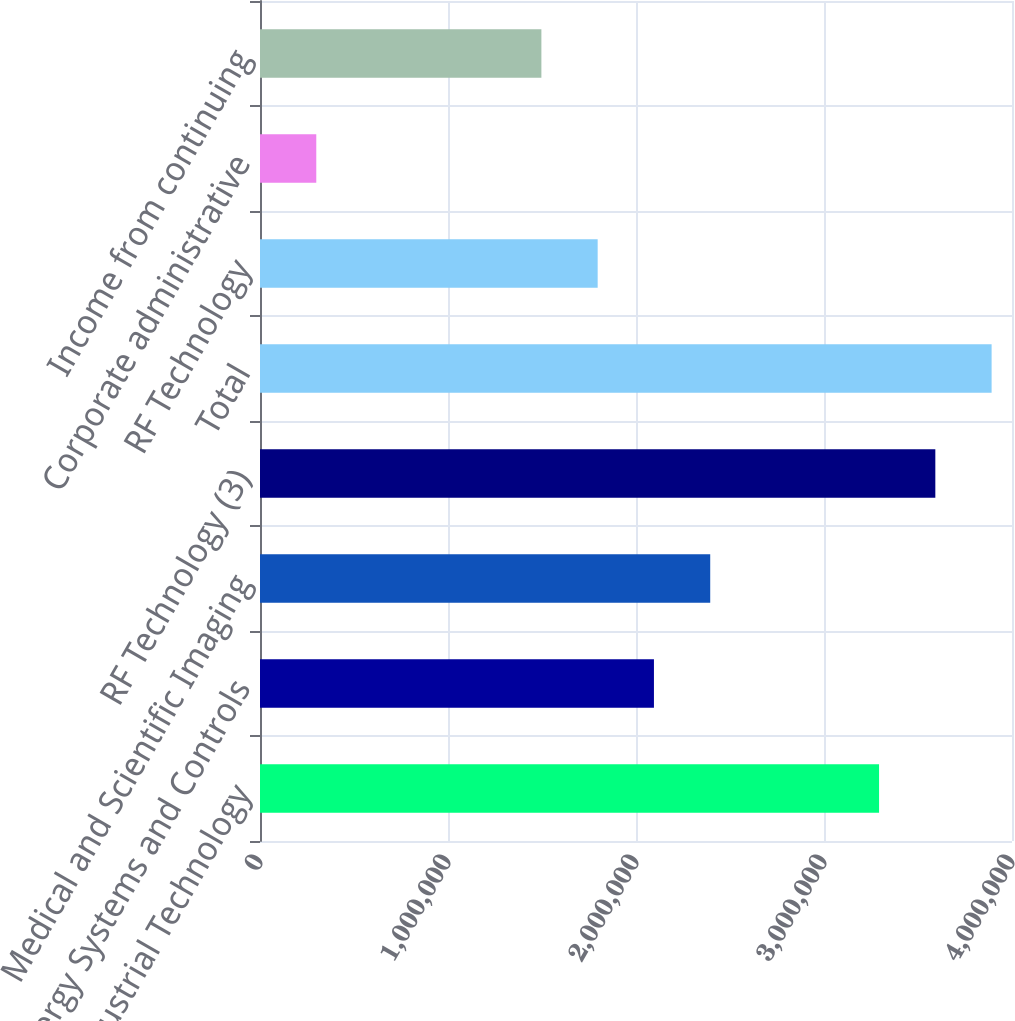Convert chart. <chart><loc_0><loc_0><loc_500><loc_500><bar_chart><fcel>Industrial Technology<fcel>Energy Systems and Controls<fcel>Medical and Scientific Imaging<fcel>RF Technology (3)<fcel>Total<fcel>RF Technology<fcel>Corporate administrative<fcel>Income from continuing<nl><fcel>3.29284e+06<fcel>2.09544e+06<fcel>2.39479e+06<fcel>3.59219e+06<fcel>3.89154e+06<fcel>1.79609e+06<fcel>299351<fcel>1.49675e+06<nl></chart> 